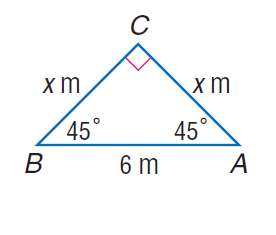Answer the mathemtical geometry problem and directly provide the correct option letter.
Question: Find x.
Choices: A: 3 B: 3 \sqrt { 2 } C: 6 D: 6 \sqrt { 2 } B 